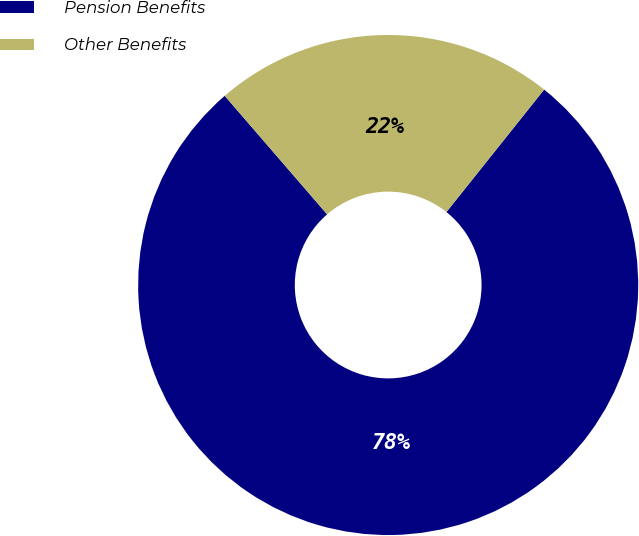Convert chart to OTSL. <chart><loc_0><loc_0><loc_500><loc_500><pie_chart><fcel>Pension Benefits<fcel>Other Benefits<nl><fcel>77.94%<fcel>22.06%<nl></chart> 